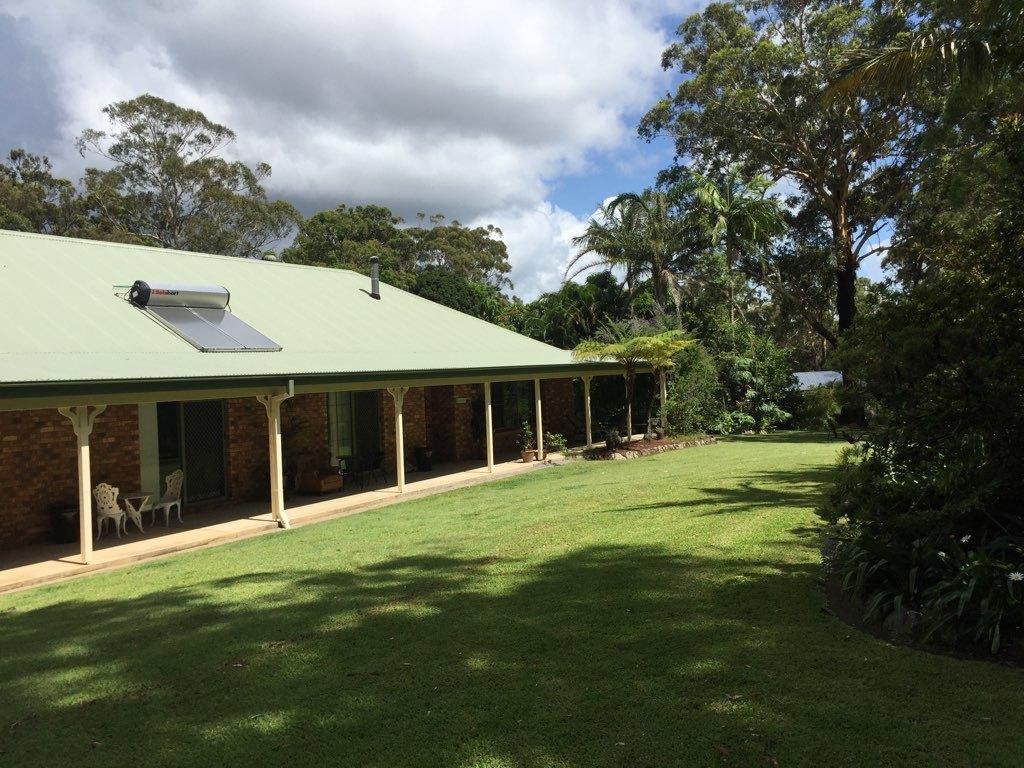Could you give a brief overview of what you see in this image? In this image we can see a house with pillars, doors and a solar panel on a roof. We can also see some chairs and plants in the pots under a roof. We can also see some grass, plants, a group of trees and the sky which looks cloudy. 